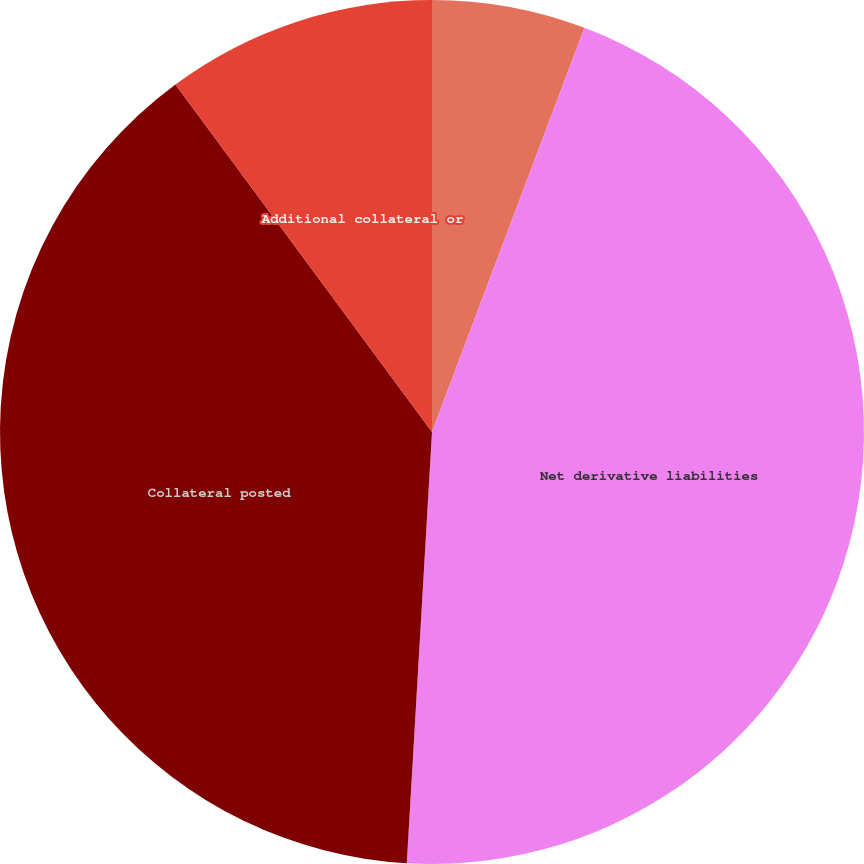Convert chart. <chart><loc_0><loc_0><loc_500><loc_500><pie_chart><fcel>in millions<fcel>Net derivative liabilities<fcel>Collateral posted<fcel>Additional collateral or<nl><fcel>5.74%<fcel>45.19%<fcel>38.95%<fcel>10.12%<nl></chart> 